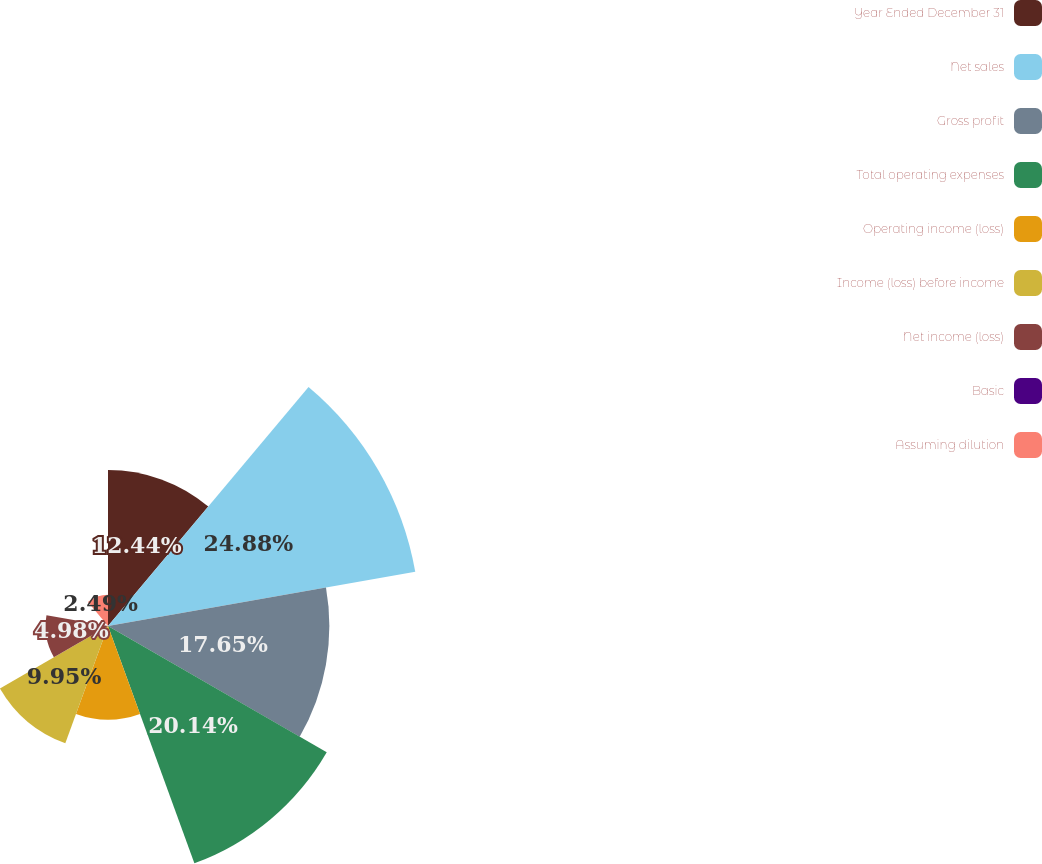Convert chart. <chart><loc_0><loc_0><loc_500><loc_500><pie_chart><fcel>Year Ended December 31<fcel>Net sales<fcel>Gross profit<fcel>Total operating expenses<fcel>Operating income (loss)<fcel>Income (loss) before income<fcel>Net income (loss)<fcel>Basic<fcel>Assuming dilution<nl><fcel>12.44%<fcel>24.88%<fcel>17.65%<fcel>20.14%<fcel>7.47%<fcel>9.95%<fcel>4.98%<fcel>0.0%<fcel>2.49%<nl></chart> 